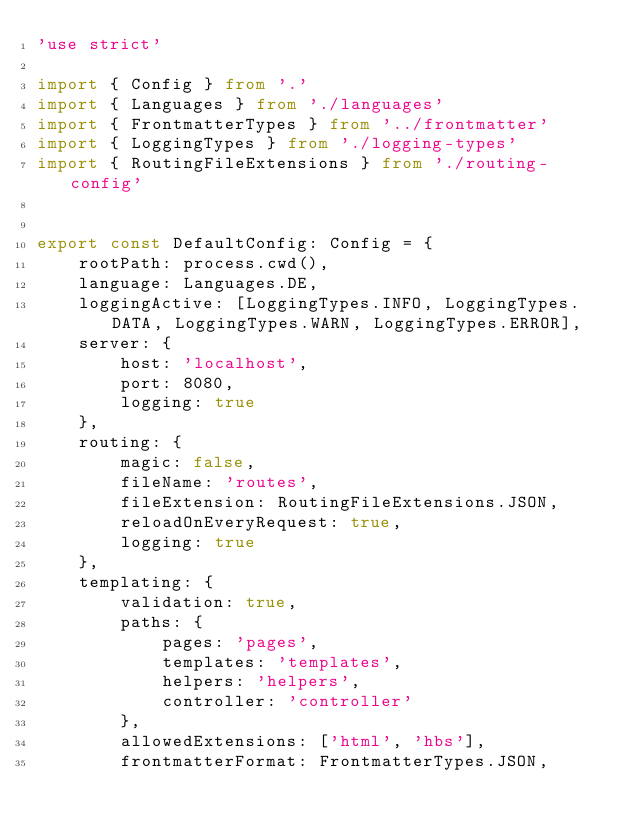Convert code to text. <code><loc_0><loc_0><loc_500><loc_500><_TypeScript_>'use strict'

import { Config } from '.'
import { Languages } from './languages'
import { FrontmatterTypes } from '../frontmatter'
import { LoggingTypes } from './logging-types'
import { RoutingFileExtensions } from './routing-config'


export const DefaultConfig: Config = {
    rootPath: process.cwd(),
    language: Languages.DE,
    loggingActive: [LoggingTypes.INFO, LoggingTypes.DATA, LoggingTypes.WARN, LoggingTypes.ERROR],
    server: {
        host: 'localhost',
        port: 8080,
        logging: true
    },
    routing: {
        magic: false,
        fileName: 'routes',
        fileExtension: RoutingFileExtensions.JSON,
        reloadOnEveryRequest: true,
        logging: true
    },
    templating: {
        validation: true,
        paths: {
            pages: 'pages',
            templates: 'templates',
            helpers: 'helpers',
            controller: 'controller'
        },
        allowedExtensions: ['html', 'hbs'],
        frontmatterFormat: FrontmatterTypes.JSON,</code> 